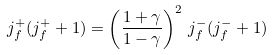Convert formula to latex. <formula><loc_0><loc_0><loc_500><loc_500>j _ { f } ^ { + } ( j _ { f } ^ { + } + 1 ) = \left ( \frac { 1 + \gamma } { 1 - \gamma } \right ) ^ { 2 } \, j _ { f } ^ { - } ( j _ { f } ^ { - } + 1 )</formula> 